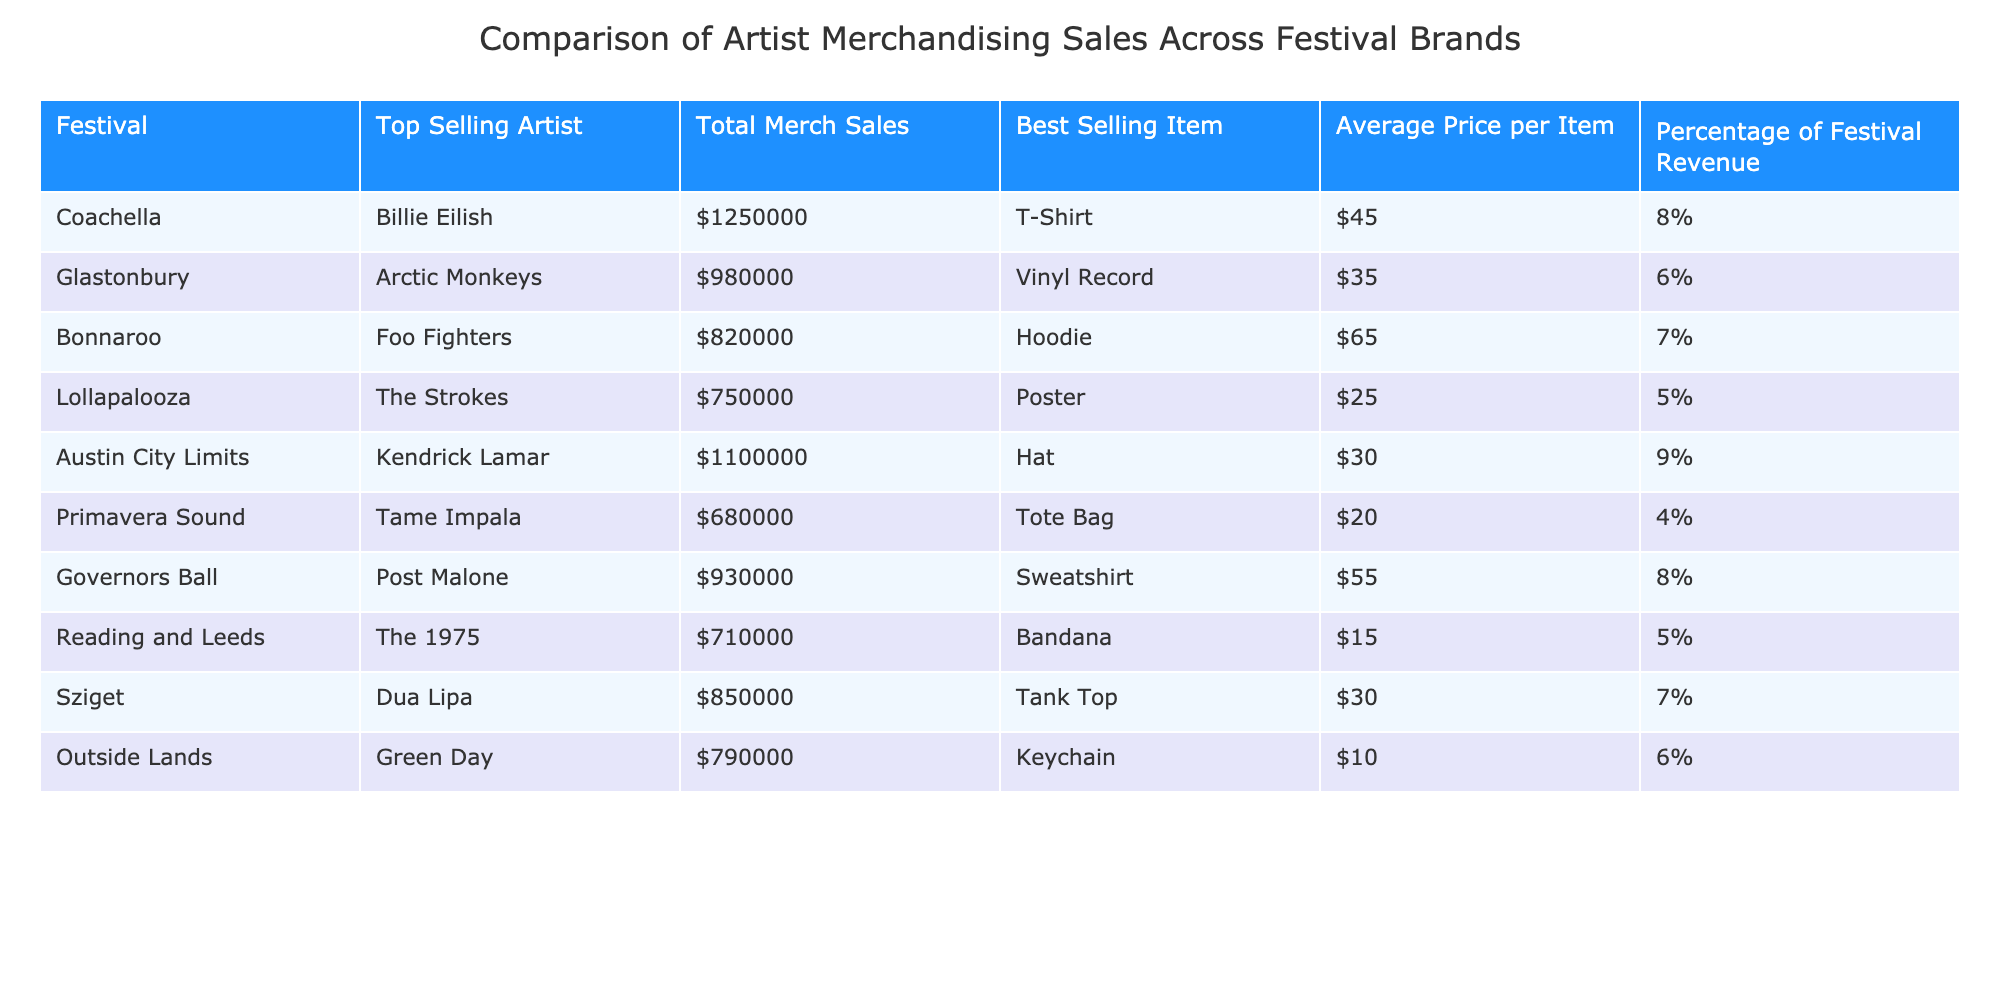What's the total merchandise sales for Coachella? The total merchandise sales for Coachella is explicitly listed in the table under "Total Merch Sales" for that festival. It is shown as $1,250,000.
Answer: $1,250,000 Which festival had the highest sales for a single item? Looking at the “Total Merch Sales” and “Best Selling Item”, Coachella has the highest sales: $1,250,000, with Billie Eilish's T-Shirt as the best-selling item.
Answer: Coachella What is the average price of items sold at Bonnaroo? The “Average Price per Item” for Bonnaroo is specifically provided in the table as $65.
Answer: $65 True or false: Sziget's total merchandise sales exceeded those of Lollapalooza. By comparing the “Total Merch Sales” values, Sziget's sales are $850,000 and Lollapalooza's are $750,000, indicating that Sziget's sales did indeed exceed those of Lollapalooza.
Answer: True What is the difference between the total merchandise sales of Austin City Limits and Primavera Sound? The sales for Austin City Limits is $1,100,000 and for Primavera Sound is $680,000. The difference is calculated as $1,100,000 - $680,000 which equals $420,000.
Answer: $420,000 Which artist's merchandise sales contributed 9% to their festival's total revenue? The table shows that merchandise sales for Kendrick Lamar at Austin City Limits contributed 9% to the festival's revenue, which is the only instance of this percentage.
Answer: Kendrick Lamar How many festivals reported merchandise sales of over $800,000? By reviewing the total sales figures in the table, the festivals with sales over $800,000 are Coachella, Austin City Limits, Glastonbury, Bonnaroo, and Sziget, totaling 5 festivals.
Answer: 5 What was the best-selling item at Governors Ball? The best-selling item specifically mentioned for Governors Ball in the table is a sweatshirt.
Answer: Sweatshirt Which festival had the lowest percentage of revenue from merchandise sales? Looking at the "Percentage of Festival Revenue" column, Primavera Sound is listed with 4%, which is the lowest among the listed festivals.
Answer: Primavera Sound 